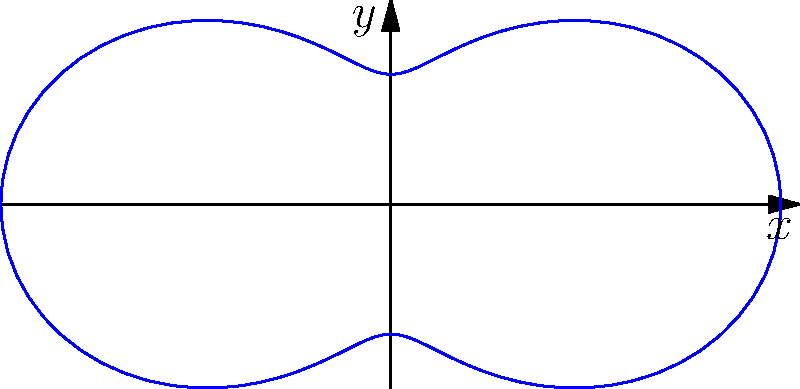As a science journalist interviewing an antenna engineer, you're shown a polar plot representing the radiation pattern of a new antenna design. The pattern is described by the equation $r = 1 + 0.5\cos(2\theta)$. What is the maximum radiation intensity, and in which direction(s) does it occur? To find the maximum radiation intensity and its direction(s), we need to follow these steps:

1) The radiation intensity is represented by the distance from the origin (r) in the polar plot.

2) The equation given is $r = 1 + 0.5\cos(2\theta)$

3) To find the maximum value of r, we need to find where $\cos(2\theta)$ is at its maximum.

4) We know that the cosine function has a maximum value of 1, which occurs when its argument is a multiple of $2\pi$.

5) So, $2\theta = 2\pi n$, where n is an integer.

6) Solving for $\theta$: $\theta = \pi n$, where n is an integer.

7) The first two solutions are when $\theta = 0$ and $\theta = \pi$, which correspond to the positive and negative x-axis directions.

8) Plugging these values back into the original equation:

   $r_{max} = 1 + 0.5\cos(2 \cdot 0) = 1 + 0.5 = 1.5$

9) Therefore, the maximum radiation intensity is 1.5 units, and it occurs along the positive and negative x-axis (0° and 180°).
Answer: 1.5 units, along 0° and 180° 